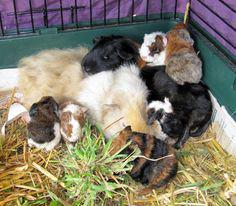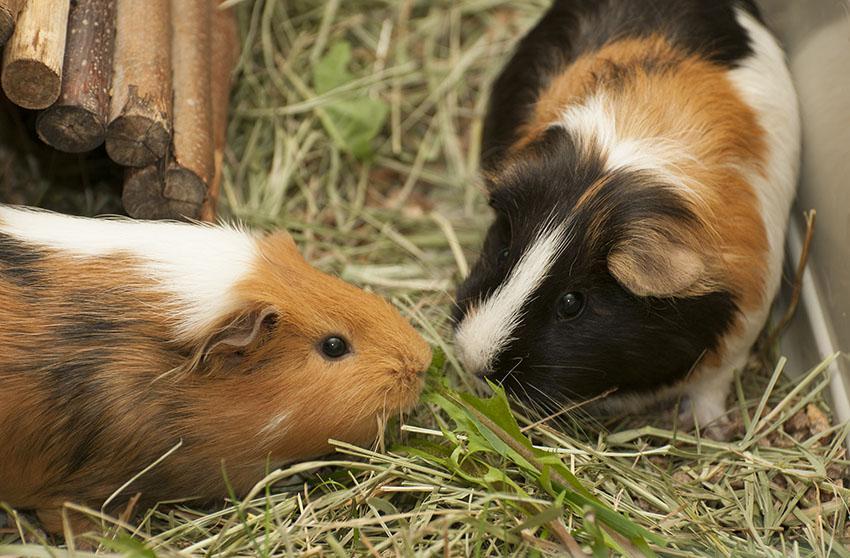The first image is the image on the left, the second image is the image on the right. Analyze the images presented: Is the assertion "There are no more than two animals in a wire cage in one of the images." valid? Answer yes or no. No. 